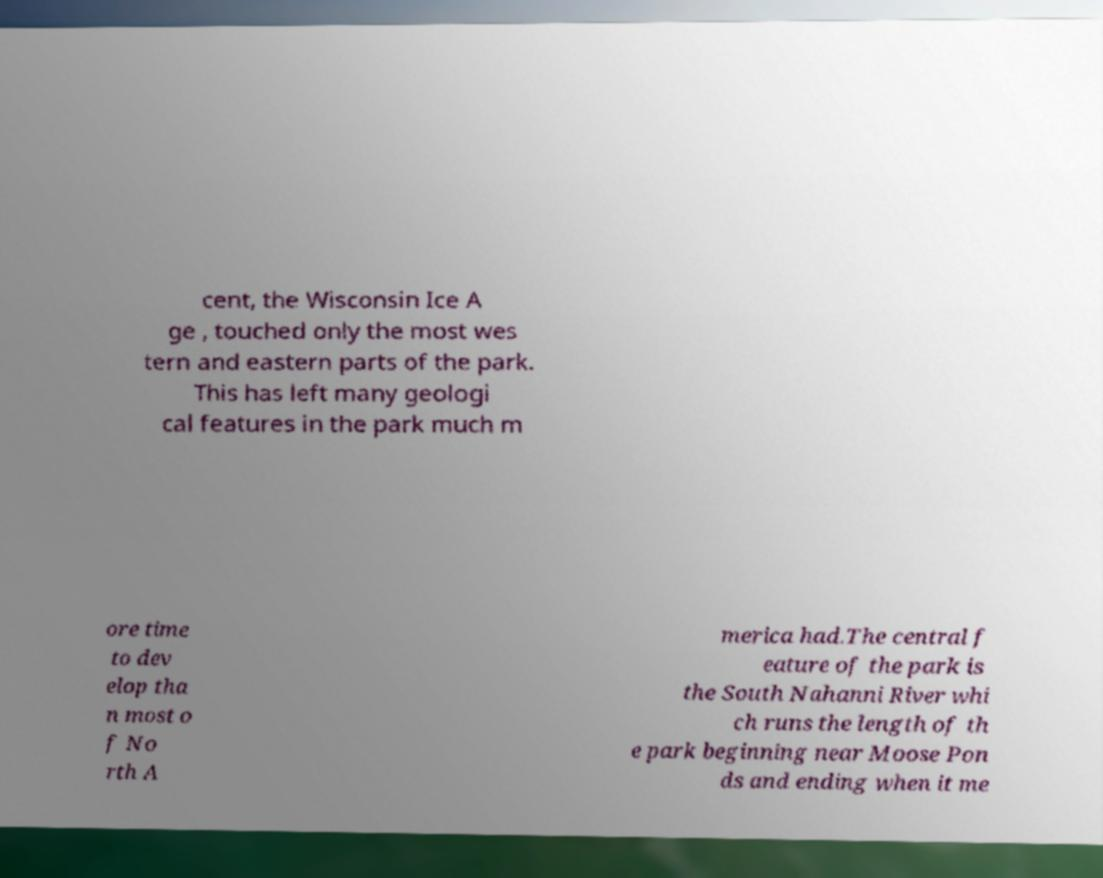Please read and relay the text visible in this image. What does it say? cent, the Wisconsin Ice A ge , touched only the most wes tern and eastern parts of the park. This has left many geologi cal features in the park much m ore time to dev elop tha n most o f No rth A merica had.The central f eature of the park is the South Nahanni River whi ch runs the length of th e park beginning near Moose Pon ds and ending when it me 